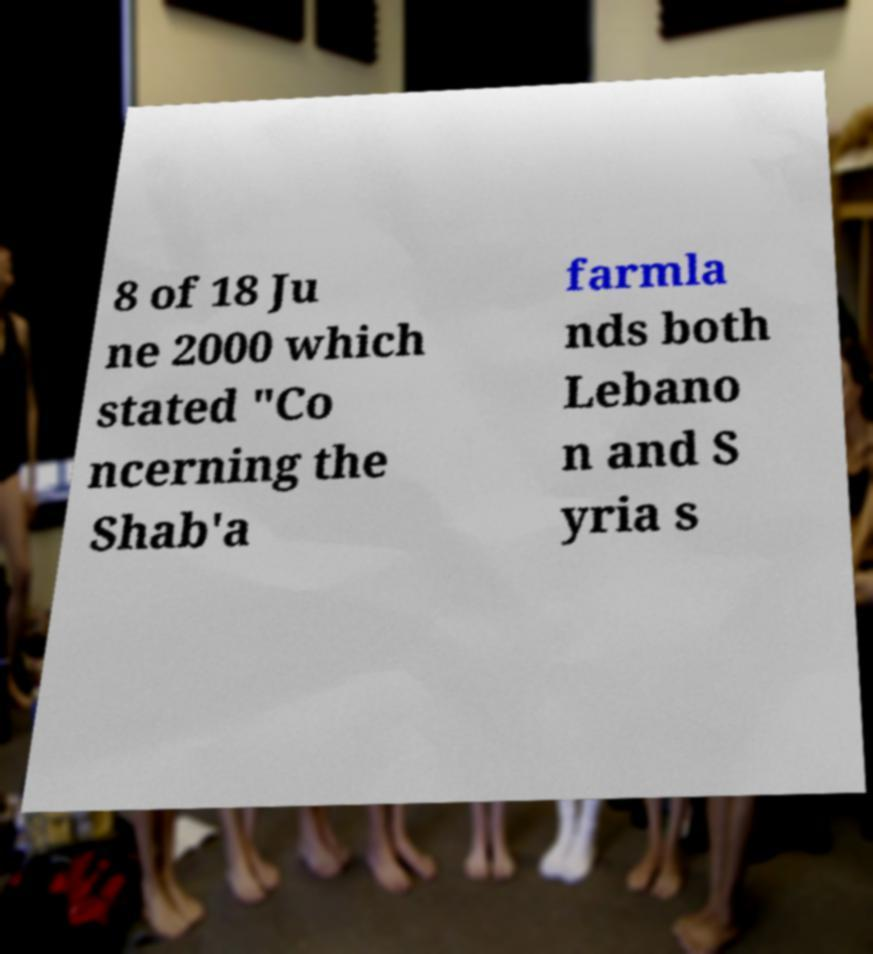What messages or text are displayed in this image? I need them in a readable, typed format. 8 of 18 Ju ne 2000 which stated "Co ncerning the Shab'a farmla nds both Lebano n and S yria s 